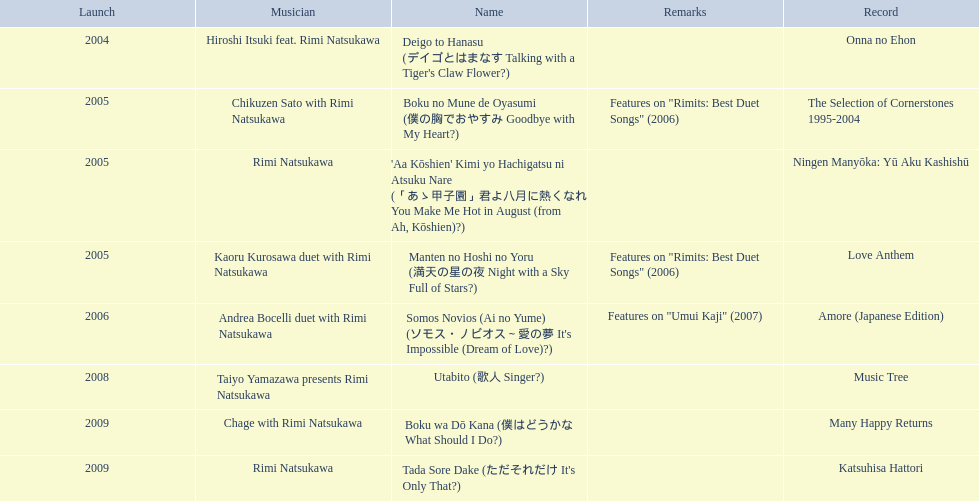Which year had the most titles released? 2005. 